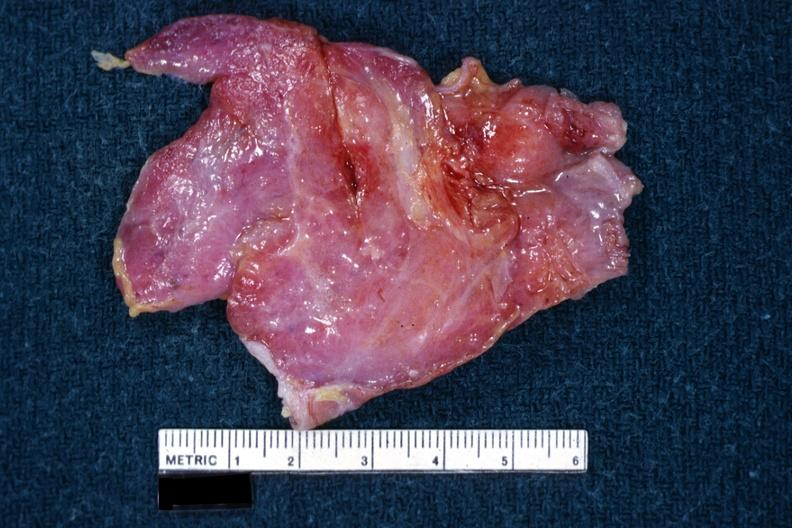what is this?
Answer the question using a single word or phrase. A thymus 